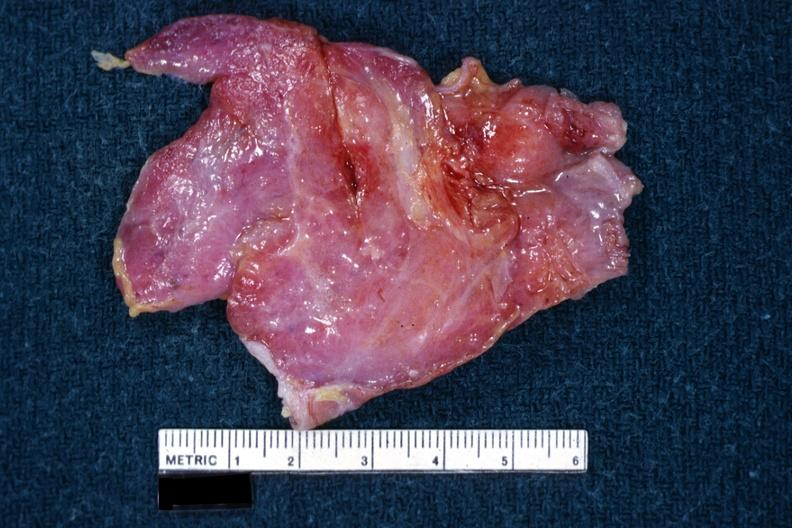what is this?
Answer the question using a single word or phrase. A thymus 